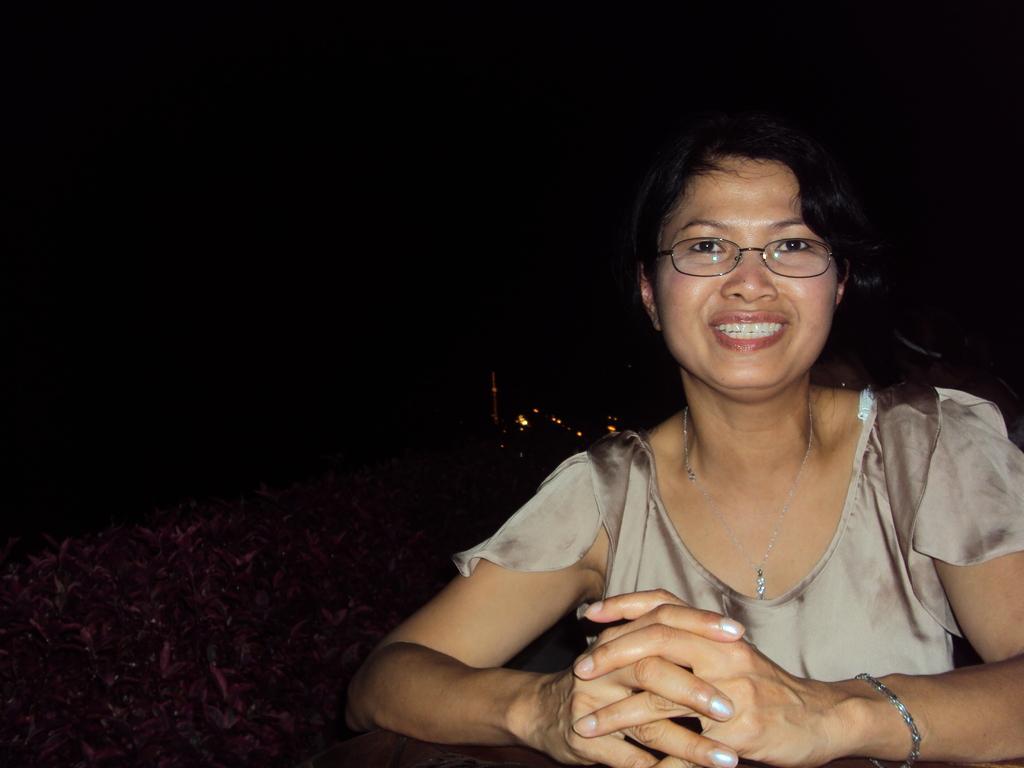How would you summarize this image in a sentence or two? There is a lady wearing specs, chain and bracelet is smiling. Near to her there are plants. In the background it is dark. 